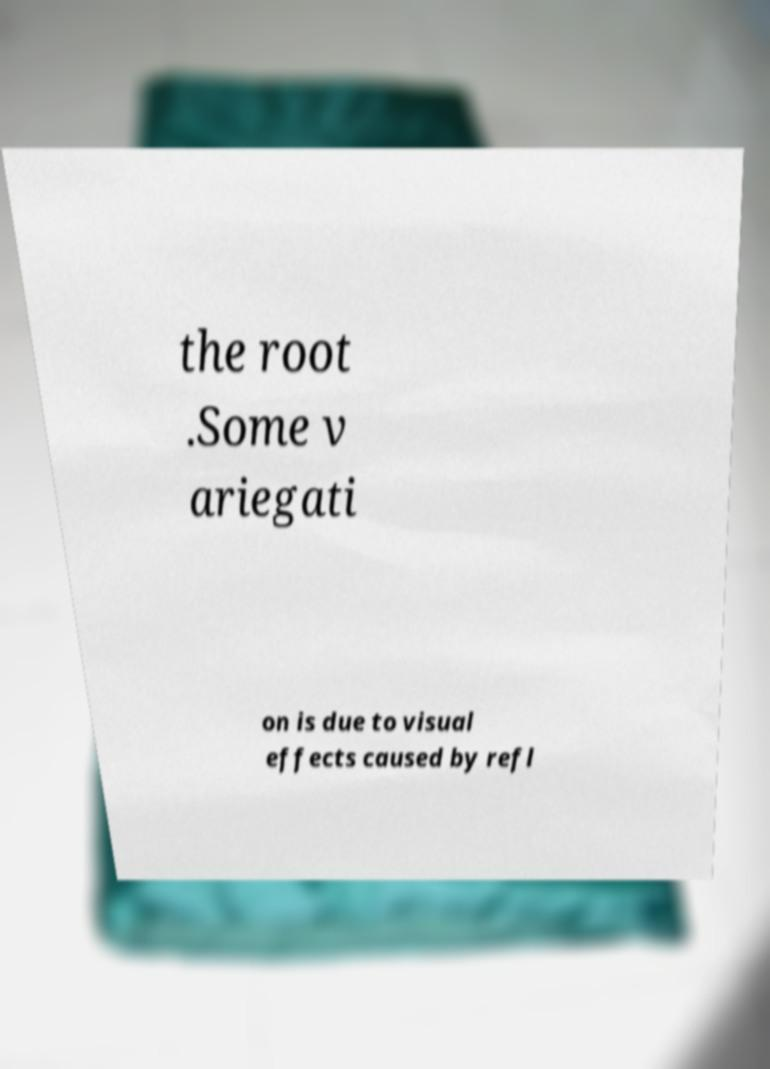I need the written content from this picture converted into text. Can you do that? the root .Some v ariegati on is due to visual effects caused by refl 